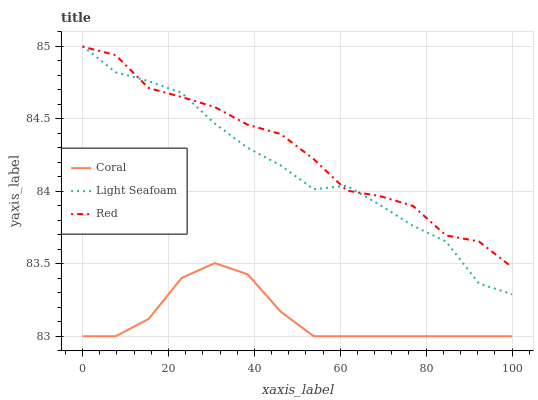Does Coral have the minimum area under the curve?
Answer yes or no. Yes. Does Red have the maximum area under the curve?
Answer yes or no. Yes. Does Light Seafoam have the minimum area under the curve?
Answer yes or no. No. Does Light Seafoam have the maximum area under the curve?
Answer yes or no. No. Is Coral the smoothest?
Answer yes or no. Yes. Is Red the roughest?
Answer yes or no. Yes. Is Light Seafoam the smoothest?
Answer yes or no. No. Is Light Seafoam the roughest?
Answer yes or no. No. Does Coral have the lowest value?
Answer yes or no. Yes. Does Light Seafoam have the lowest value?
Answer yes or no. No. Does Light Seafoam have the highest value?
Answer yes or no. Yes. Does Red have the highest value?
Answer yes or no. No. Is Coral less than Light Seafoam?
Answer yes or no. Yes. Is Red greater than Coral?
Answer yes or no. Yes. Does Light Seafoam intersect Red?
Answer yes or no. Yes. Is Light Seafoam less than Red?
Answer yes or no. No. Is Light Seafoam greater than Red?
Answer yes or no. No. Does Coral intersect Light Seafoam?
Answer yes or no. No. 